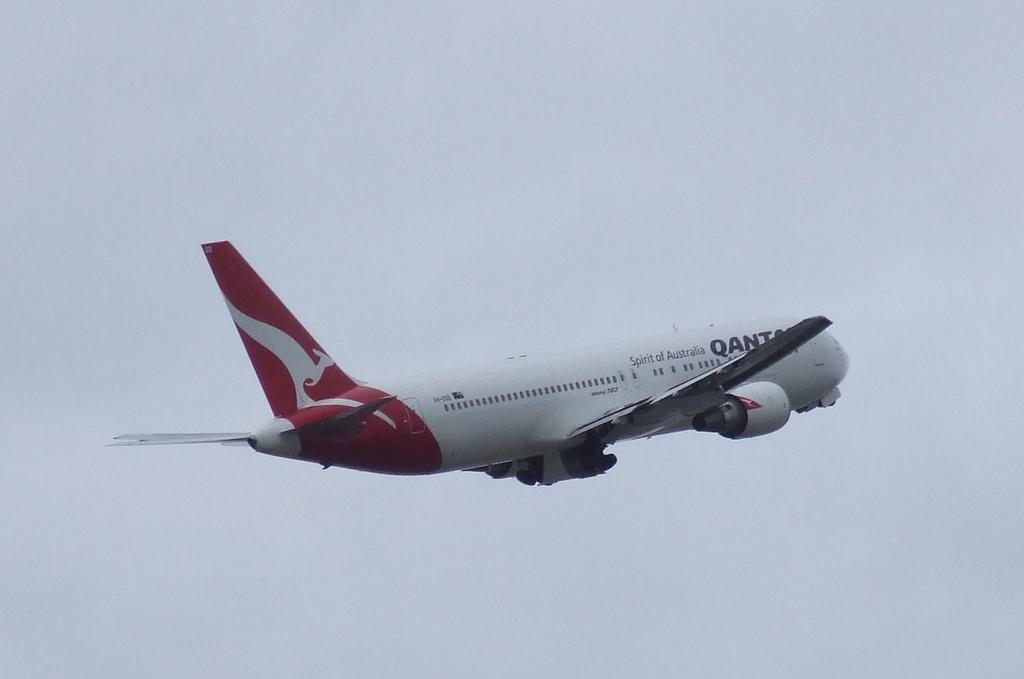What is the main subject of the image? The main subject of the image is an aeroplane. What colors can be seen on the aeroplane? The aeroplane is white, blue, and red in color. What is the aeroplane doing in the image? The aeroplane is flying in the air. What can be seen in the background of the image? The sky is visible in the background of the image. What type of prose can be heard being read by the aeroplane in the image? There is no indication in the image that the aeroplane is reading or producing any prose. 